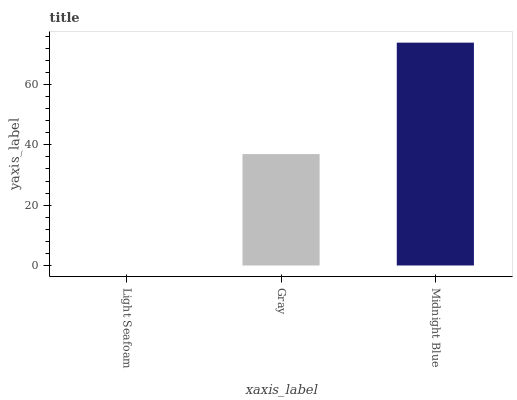Is Light Seafoam the minimum?
Answer yes or no. Yes. Is Midnight Blue the maximum?
Answer yes or no. Yes. Is Gray the minimum?
Answer yes or no. No. Is Gray the maximum?
Answer yes or no. No. Is Gray greater than Light Seafoam?
Answer yes or no. Yes. Is Light Seafoam less than Gray?
Answer yes or no. Yes. Is Light Seafoam greater than Gray?
Answer yes or no. No. Is Gray less than Light Seafoam?
Answer yes or no. No. Is Gray the high median?
Answer yes or no. Yes. Is Gray the low median?
Answer yes or no. Yes. Is Midnight Blue the high median?
Answer yes or no. No. Is Light Seafoam the low median?
Answer yes or no. No. 